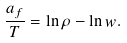Convert formula to latex. <formula><loc_0><loc_0><loc_500><loc_500>\frac { a _ { f } } { T } = \ln \rho - \ln w .</formula> 